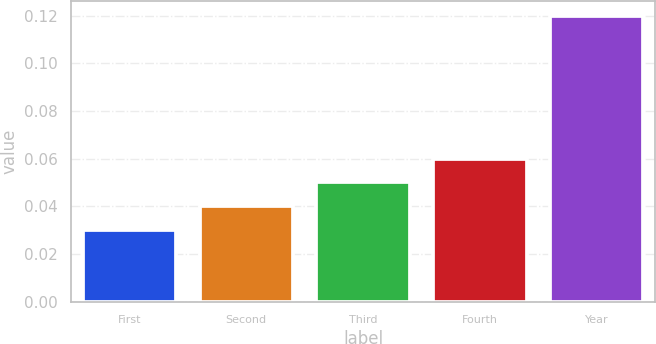<chart> <loc_0><loc_0><loc_500><loc_500><bar_chart><fcel>First<fcel>Second<fcel>Third<fcel>Fourth<fcel>Year<nl><fcel>0.03<fcel>0.04<fcel>0.05<fcel>0.06<fcel>0.12<nl></chart> 